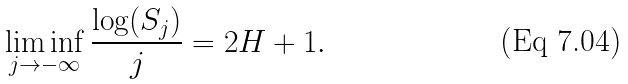Convert formula to latex. <formula><loc_0><loc_0><loc_500><loc_500>\liminf _ { j \rightarrow - \infty } \frac { \log ( S _ { j } ) } { j } = 2 H + 1 .</formula> 